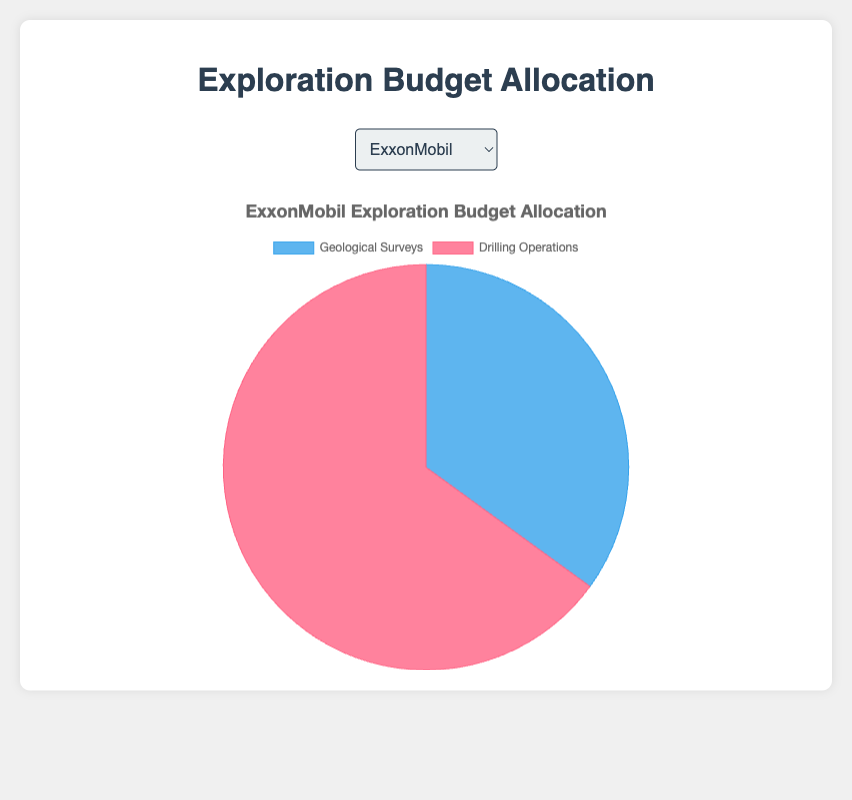What's the percentage of budget allocation for Geological Surveys in Chevron? The pie chart for Chevron shows two segments, one for Geological Surveys and one for Drilling Operations. The percentage shown for Geological Surveys is 40%.
Answer: 40% How does BP's budget allocation for Drilling Operations compare to Shell's? BP allocates 55% to Drilling Operations, while Shell allocates 70%. Since 55% is less than 70%, BP spends a smaller percentage on Drilling Operations compared to Shell.
Answer: BP allocates less than Shell Which company has the largest allocation to Geological Surveys? Observing the pie charts, BP shows the highest percentage allocation for Geological Surveys at 45%.
Answer: BP What's the combined percentage of budget allocation to Geological Surveys for ExxonMobil and TotalEnergies? The pie charts indicate that ExxonMobil allocates 35% and TotalEnergies allocates 38% to Geological Surveys. Adding these together, 35% + 38% = 73%.
Answer: 73% Which company allocates a greater percentage to Geological Surveys, Saudi Aramco or ExxonMobil? The pie chart for Saudi Aramco shows a 33% allocation to Geological Surveys, while ExxonMobil shows a 35% allocation. Since 35% is greater than 33%, ExxonMobil allocates a greater percentage.
Answer: ExxonMobil What is the average allocation to Drilling Operations across all companies? Adding the percentages for Drilling Operations: 65% (ExxonMobil) + 60% (Chevron) + 70% (Shell) + 55% (BP) + 62% (TotalEnergies) + 67% (Saudi Aramco) gives a total of 379%. Dividing by 6 companies, the average is 379% / 6 = ~63.17%.
Answer: ~63.17% In terms of visual representation, which color represents Geological Surveys in the pie charts? Observing the charts, Geological Surveys are consistently represented by a shade of blue in all pie charts.
Answer: Blue 